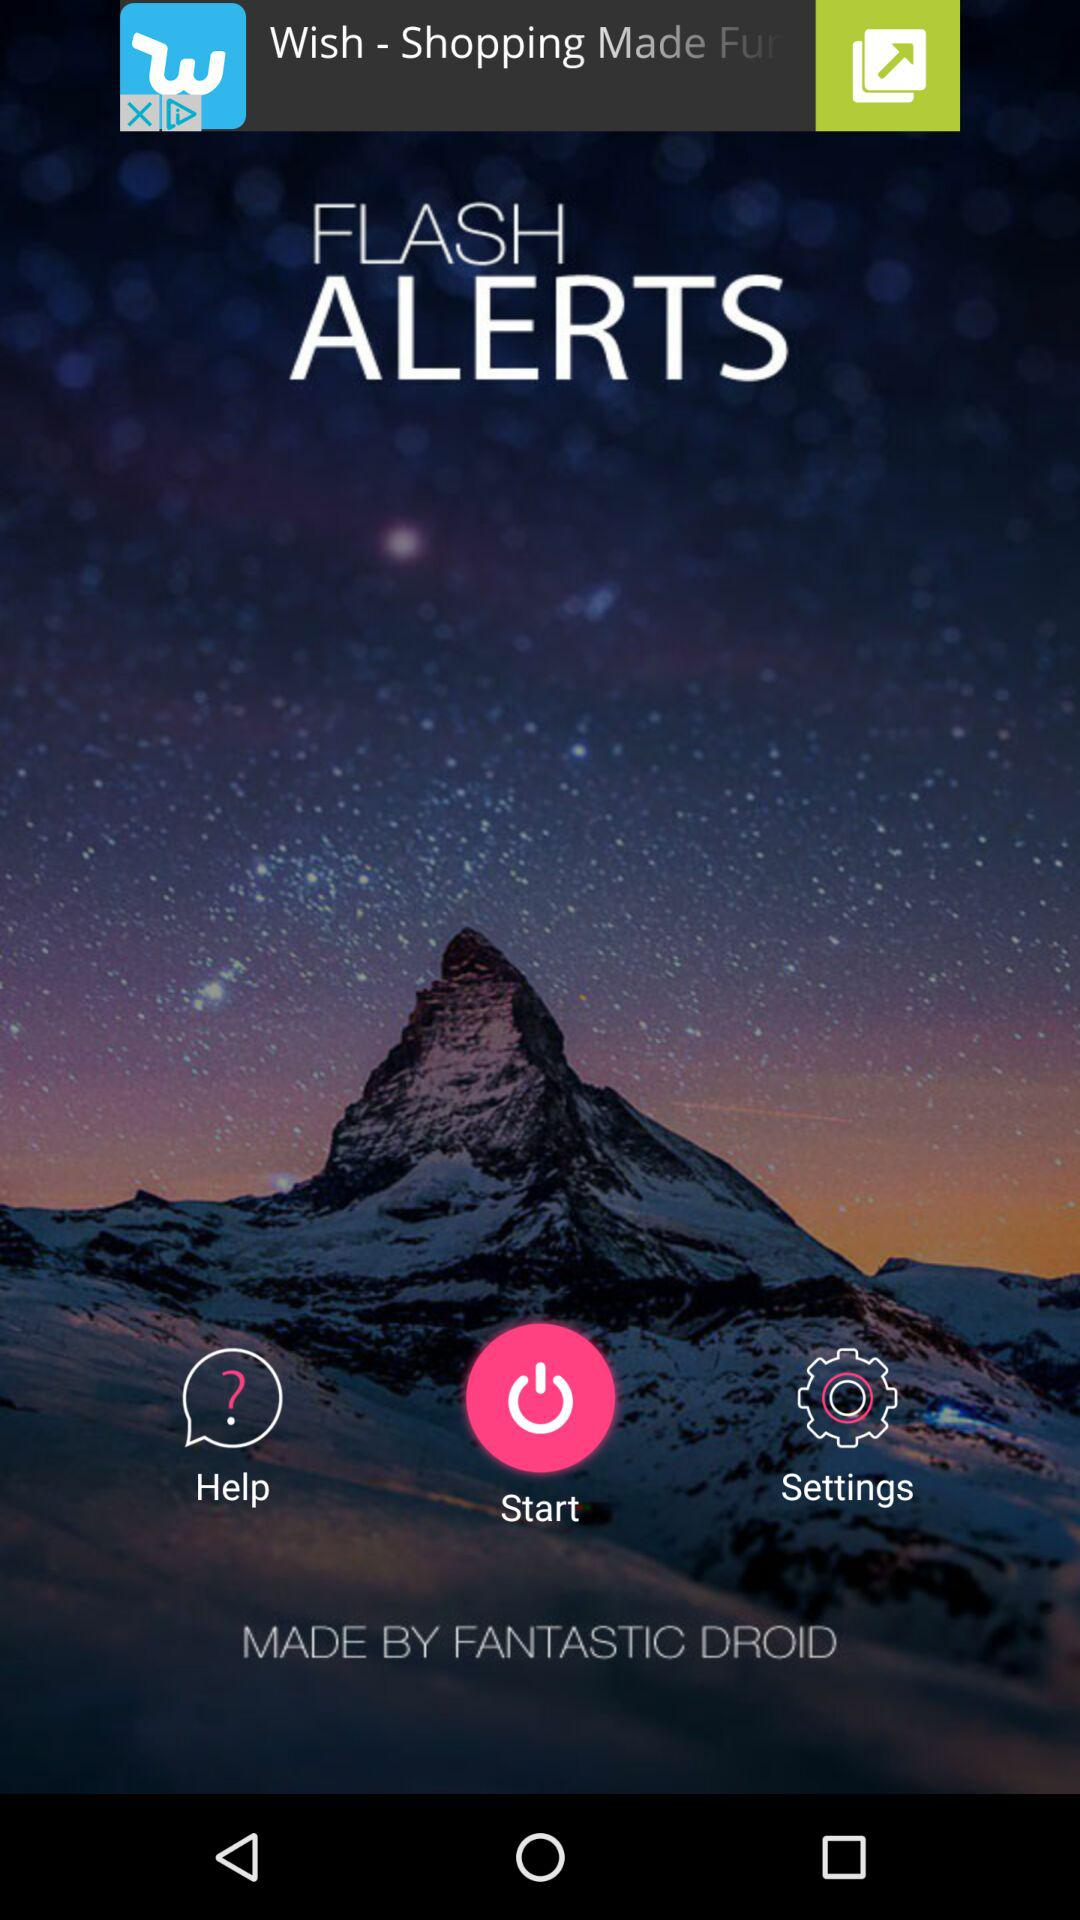What is the name of the application? The name of the application is "FLASH ALERTS". 